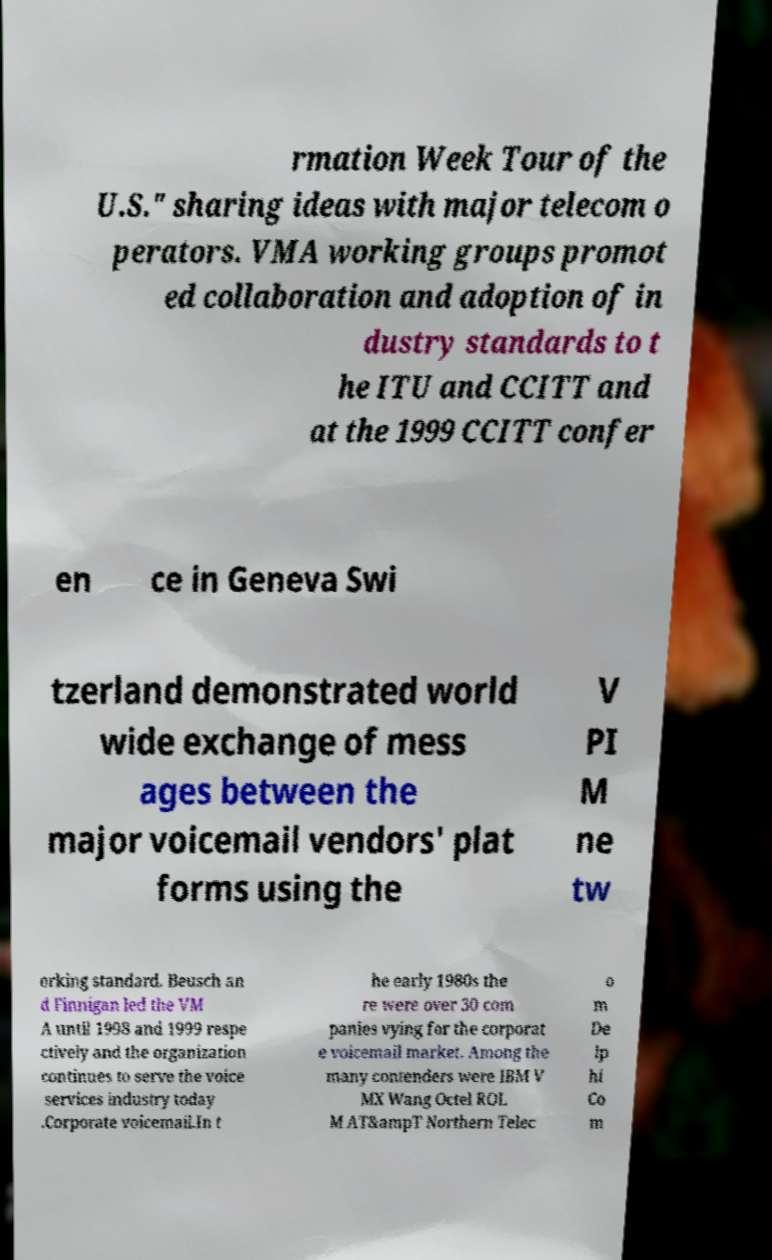Can you read and provide the text displayed in the image?This photo seems to have some interesting text. Can you extract and type it out for me? rmation Week Tour of the U.S." sharing ideas with major telecom o perators. VMA working groups promot ed collaboration and adoption of in dustry standards to t he ITU and CCITT and at the 1999 CCITT confer en ce in Geneva Swi tzerland demonstrated world wide exchange of mess ages between the major voicemail vendors' plat forms using the V PI M ne tw orking standard. Beusch an d Finnigan led the VM A until 1998 and 1999 respe ctively and the organization continues to serve the voice services industry today .Corporate voicemail.In t he early 1980s the re were over 30 com panies vying for the corporat e voicemail market. Among the many contenders were IBM V MX Wang Octel ROL M AT&ampT Northern Telec o m De lp hi Co m 